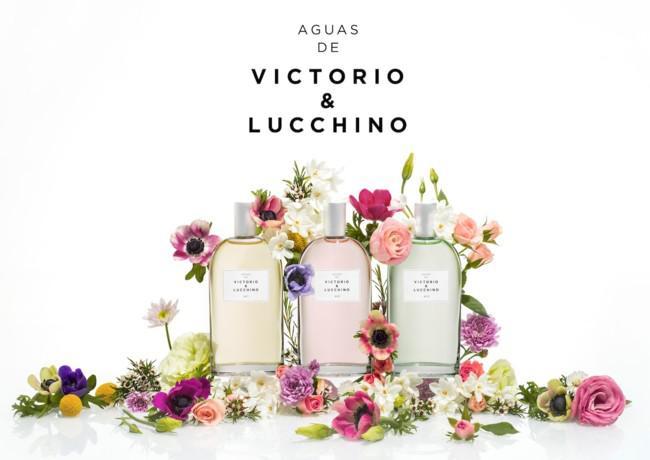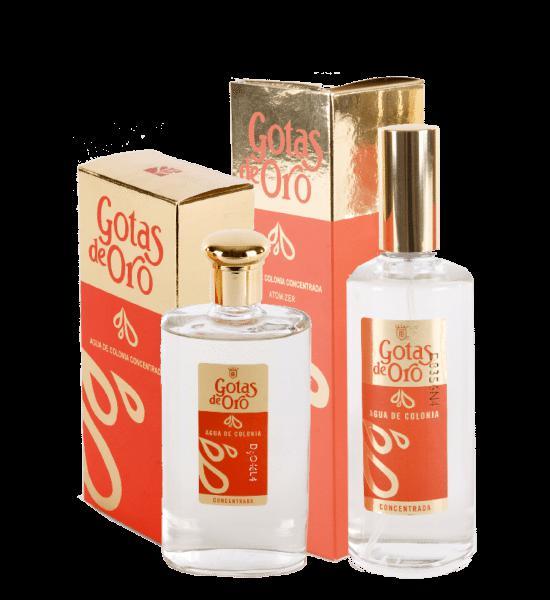The first image is the image on the left, the second image is the image on the right. Assess this claim about the two images: "Some of the bottles are surrounded by flowers.". Correct or not? Answer yes or no. Yes. The first image is the image on the left, the second image is the image on the right. Analyze the images presented: Is the assertion "One of the images shows three bottles of perfume surrounded by flowers." valid? Answer yes or no. Yes. 